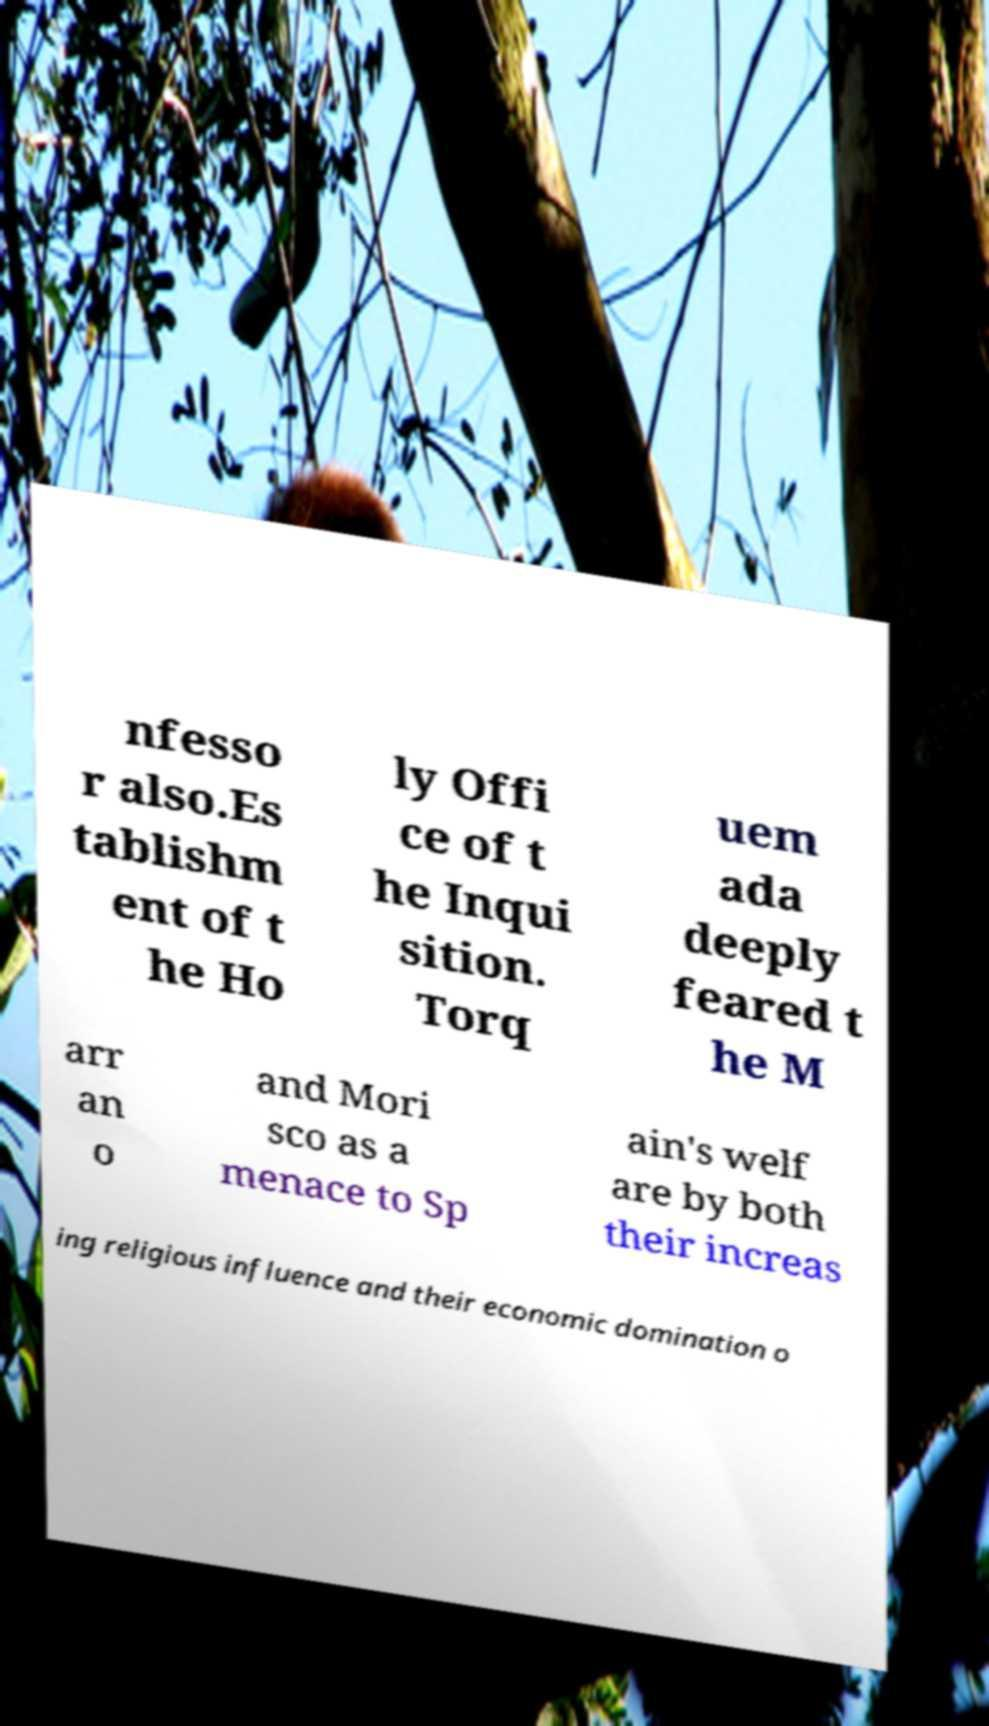Can you accurately transcribe the text from the provided image for me? nfesso r also.Es tablishm ent of t he Ho ly Offi ce of t he Inqui sition. Torq uem ada deeply feared t he M arr an o and Mori sco as a menace to Sp ain's welf are by both their increas ing religious influence and their economic domination o 